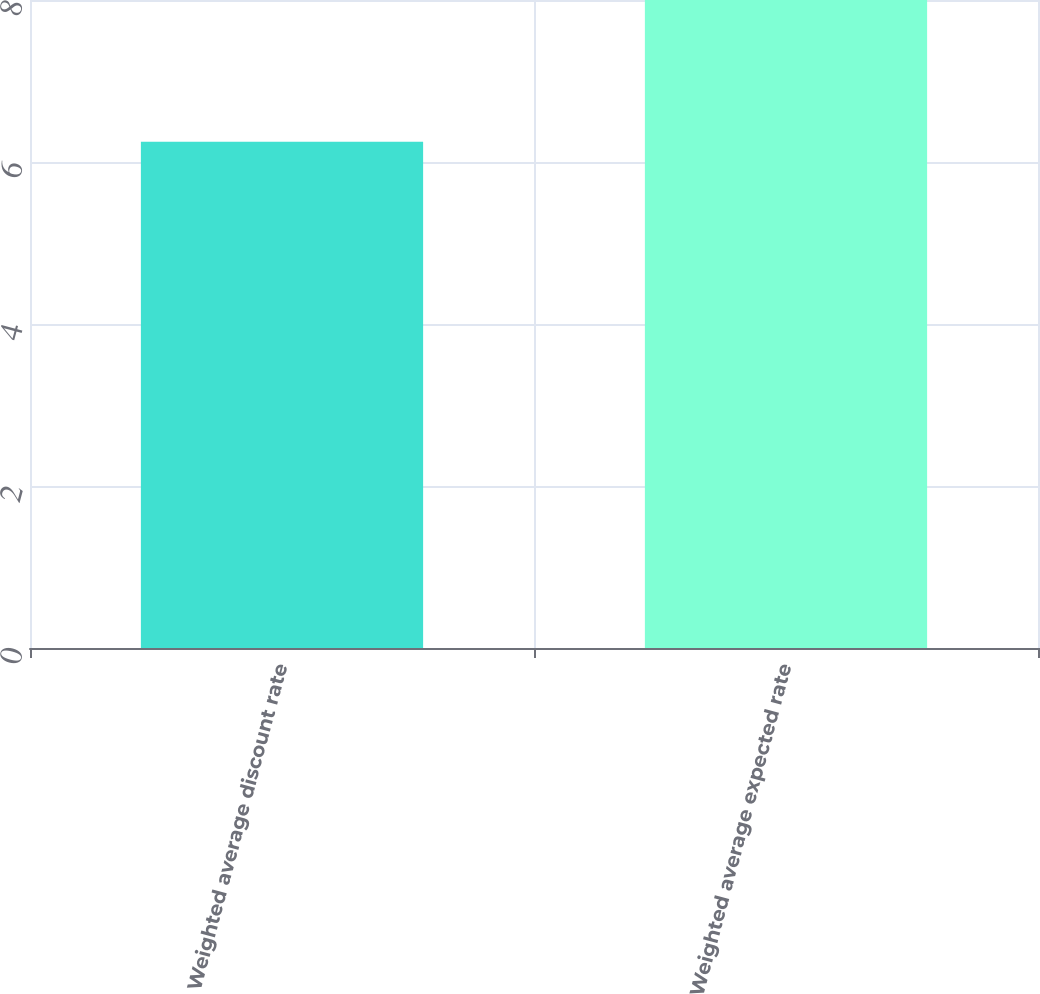Convert chart. <chart><loc_0><loc_0><loc_500><loc_500><bar_chart><fcel>Weighted average discount rate<fcel>Weighted average expected rate<nl><fcel>6.25<fcel>8<nl></chart> 